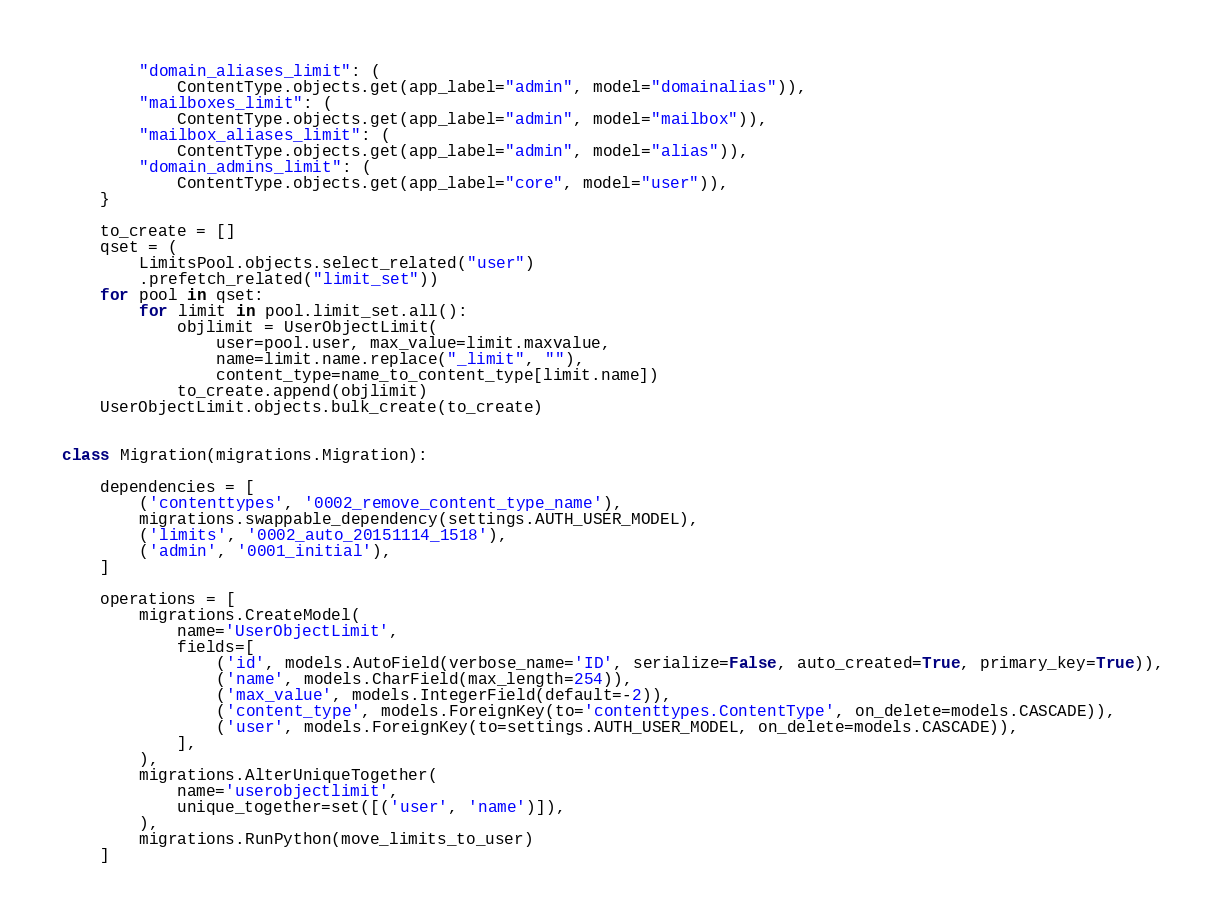<code> <loc_0><loc_0><loc_500><loc_500><_Python_>        "domain_aliases_limit": (
            ContentType.objects.get(app_label="admin", model="domainalias")),
        "mailboxes_limit": (
            ContentType.objects.get(app_label="admin", model="mailbox")),
        "mailbox_aliases_limit": (
            ContentType.objects.get(app_label="admin", model="alias")),
        "domain_admins_limit": (
            ContentType.objects.get(app_label="core", model="user")),
    }

    to_create = []
    qset = (
        LimitsPool.objects.select_related("user")
        .prefetch_related("limit_set"))
    for pool in qset:
        for limit in pool.limit_set.all():
            objlimit = UserObjectLimit(
                user=pool.user, max_value=limit.maxvalue,
                name=limit.name.replace("_limit", ""),
                content_type=name_to_content_type[limit.name])
            to_create.append(objlimit)
    UserObjectLimit.objects.bulk_create(to_create)


class Migration(migrations.Migration):

    dependencies = [
        ('contenttypes', '0002_remove_content_type_name'),
        migrations.swappable_dependency(settings.AUTH_USER_MODEL),
        ('limits', '0002_auto_20151114_1518'),
        ('admin', '0001_initial'),
    ]

    operations = [
        migrations.CreateModel(
            name='UserObjectLimit',
            fields=[
                ('id', models.AutoField(verbose_name='ID', serialize=False, auto_created=True, primary_key=True)),
                ('name', models.CharField(max_length=254)),
                ('max_value', models.IntegerField(default=-2)),
                ('content_type', models.ForeignKey(to='contenttypes.ContentType', on_delete=models.CASCADE)),
                ('user', models.ForeignKey(to=settings.AUTH_USER_MODEL, on_delete=models.CASCADE)),
            ],
        ),
        migrations.AlterUniqueTogether(
            name='userobjectlimit',
            unique_together=set([('user', 'name')]),
        ),
        migrations.RunPython(move_limits_to_user)
    ]
</code> 